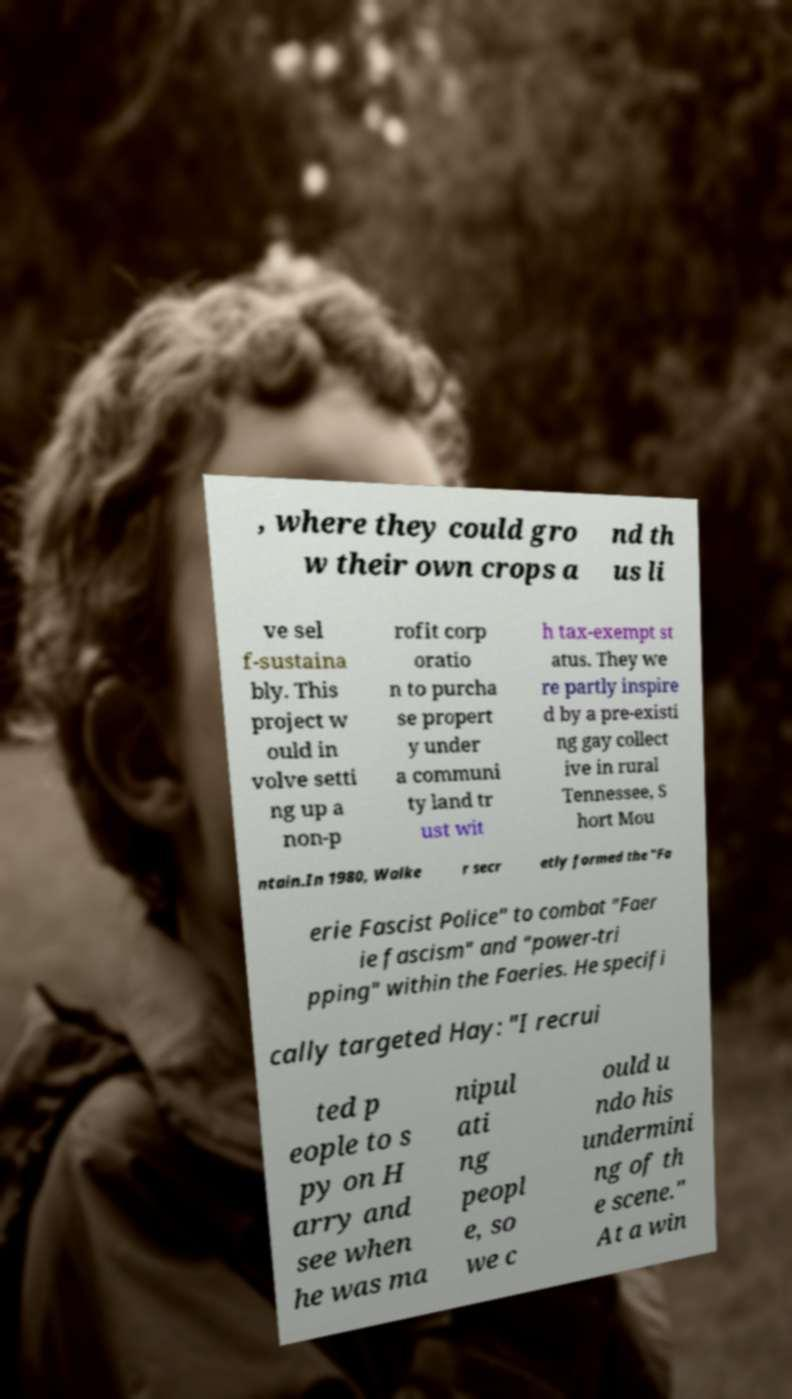What messages or text are displayed in this image? I need them in a readable, typed format. , where they could gro w their own crops a nd th us li ve sel f-sustaina bly. This project w ould in volve setti ng up a non-p rofit corp oratio n to purcha se propert y under a communi ty land tr ust wit h tax-exempt st atus. They we re partly inspire d by a pre-existi ng gay collect ive in rural Tennessee, S hort Mou ntain.In 1980, Walke r secr etly formed the "Fa erie Fascist Police" to combat "Faer ie fascism" and "power-tri pping" within the Faeries. He specifi cally targeted Hay: "I recrui ted p eople to s py on H arry and see when he was ma nipul ati ng peopl e, so we c ould u ndo his undermini ng of th e scene." At a win 